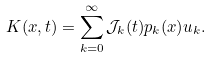Convert formula to latex. <formula><loc_0><loc_0><loc_500><loc_500>K ( x , t ) = \sum _ { k = 0 } ^ { \infty } \mathcal { J } _ { k } ( t ) p _ { k } ( x ) u _ { k } .</formula> 